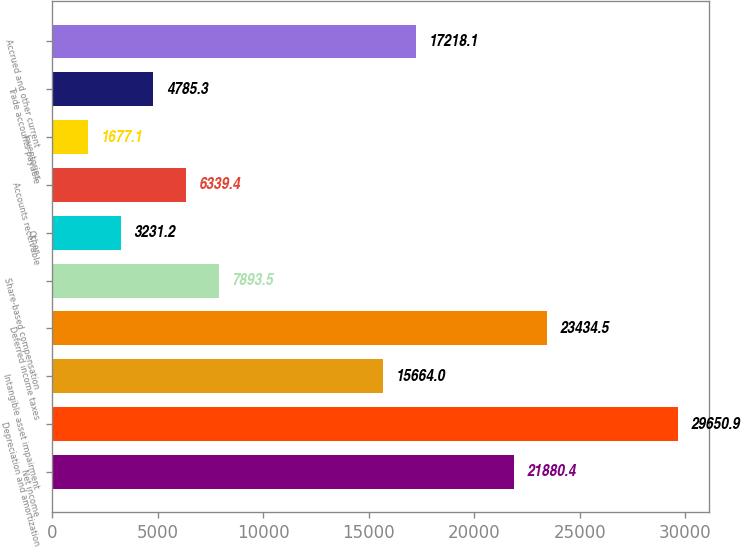Convert chart to OTSL. <chart><loc_0><loc_0><loc_500><loc_500><bar_chart><fcel>Net income<fcel>Depreciation and amortization<fcel>Intangible asset impairment<fcel>Deferred income taxes<fcel>Share-based compensation<fcel>Other<fcel>Accounts receivable<fcel>Inventories<fcel>Trade accounts payable<fcel>Accrued and other current<nl><fcel>21880.4<fcel>29650.9<fcel>15664<fcel>23434.5<fcel>7893.5<fcel>3231.2<fcel>6339.4<fcel>1677.1<fcel>4785.3<fcel>17218.1<nl></chart> 